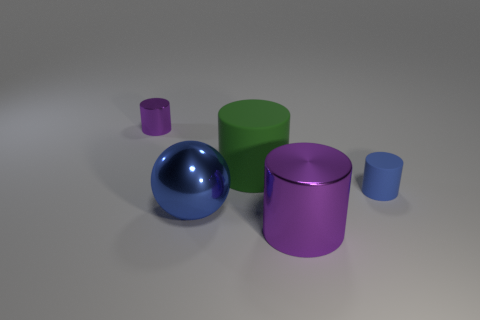Add 5 blue objects. How many objects exist? 10 Subtract all cylinders. How many objects are left? 1 Subtract 0 cyan blocks. How many objects are left? 5 Subtract all green shiny cylinders. Subtract all shiny balls. How many objects are left? 4 Add 4 blue metal balls. How many blue metal balls are left? 5 Add 3 small yellow cylinders. How many small yellow cylinders exist? 3 